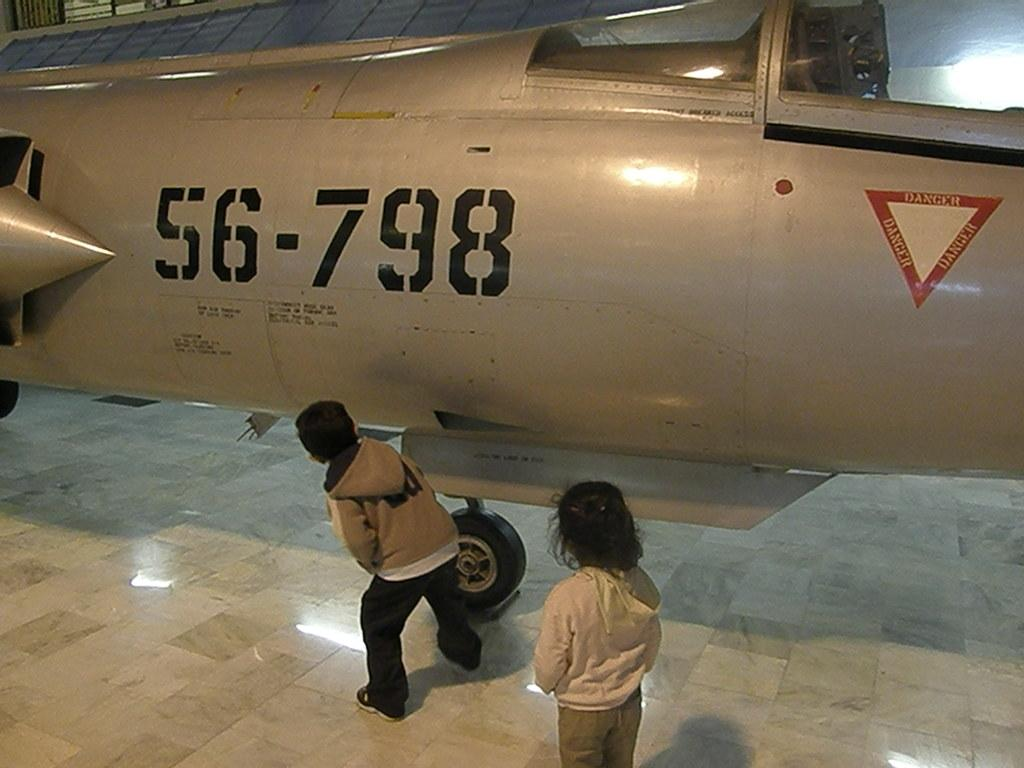<image>
Offer a succinct explanation of the picture presented. An airplane with 56-798 labeled on the side of the body. 